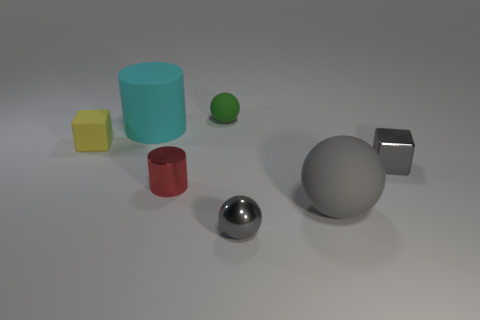There is a matte ball that is the same color as the metallic block; what is its size?
Your response must be concise. Large. There is a cyan object; is it the same size as the cylinder that is in front of the cyan thing?
Your answer should be very brief. No. There is a rubber thing to the left of the cyan rubber cylinder; what shape is it?
Provide a succinct answer. Cube. Are there more cubes on the right side of the small gray ball than blue matte cubes?
Ensure brevity in your answer.  Yes. There is a gray metallic thing behind the large rubber thing in front of the small yellow rubber object; what number of small green things are on the right side of it?
Ensure brevity in your answer.  0. Is the size of the object that is in front of the large gray rubber sphere the same as the cube on the left side of the large cyan cylinder?
Your answer should be very brief. Yes. What material is the big object that is behind the yellow rubber cube in front of the green matte sphere?
Keep it short and to the point. Rubber. How many things are either large things that are on the left side of the tiny shiny ball or large green blocks?
Make the answer very short. 1. Are there an equal number of gray metal spheres that are behind the shiny sphere and tiny blocks on the left side of the green sphere?
Provide a short and direct response. No. What is the material of the tiny cube that is to the right of the rubber ball that is right of the gray metal object in front of the big rubber ball?
Offer a terse response. Metal. 